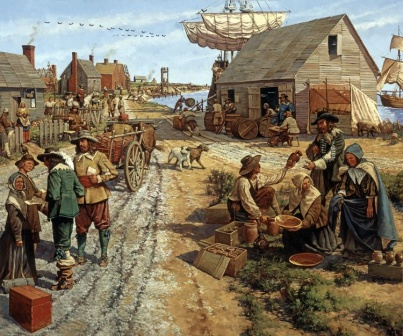If you could ask one person in this image about their life, who would you choose and why? I would choose to speak with the man balancing the basket of fruit on his head. He seems to be a central figure in this village scene, likely interacting with many people on a daily basis. His stories and experiences could provide a rich and detailed perspective on the daily life, challenges, and social dynamics of the village. Learning about his routines, the people he meets, and his insights into the marketplace could offer a valuable understanding of the economic and cultural aspects of this era. 